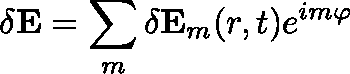Convert formula to latex. <formula><loc_0><loc_0><loc_500><loc_500>\delta E = \sum _ { m } \delta E _ { m } ( r , t ) e ^ { i m \varphi }</formula> 